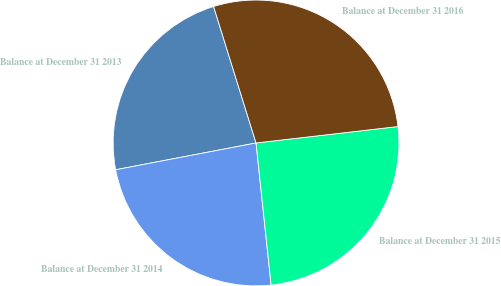<chart> <loc_0><loc_0><loc_500><loc_500><pie_chart><fcel>Balance at December 31 2013<fcel>Balance at December 31 2014<fcel>Balance at December 31 2015<fcel>Balance at December 31 2016<nl><fcel>23.2%<fcel>23.68%<fcel>25.15%<fcel>27.96%<nl></chart> 